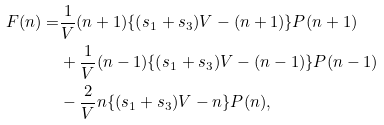Convert formula to latex. <formula><loc_0><loc_0><loc_500><loc_500>F ( n ) = & \frac { 1 } { V } ( n + 1 ) \{ ( s _ { 1 } + s _ { 3 } ) V - ( n + 1 ) \} P ( n + 1 ) \\ & + \frac { 1 } { V } ( n - 1 ) \{ ( s _ { 1 } + s _ { 3 } ) V - ( n - 1 ) \} P ( n - 1 ) \\ & - \frac { 2 } { V } n \{ ( s _ { 1 } + s _ { 3 } ) V - n \} P ( n ) ,</formula> 